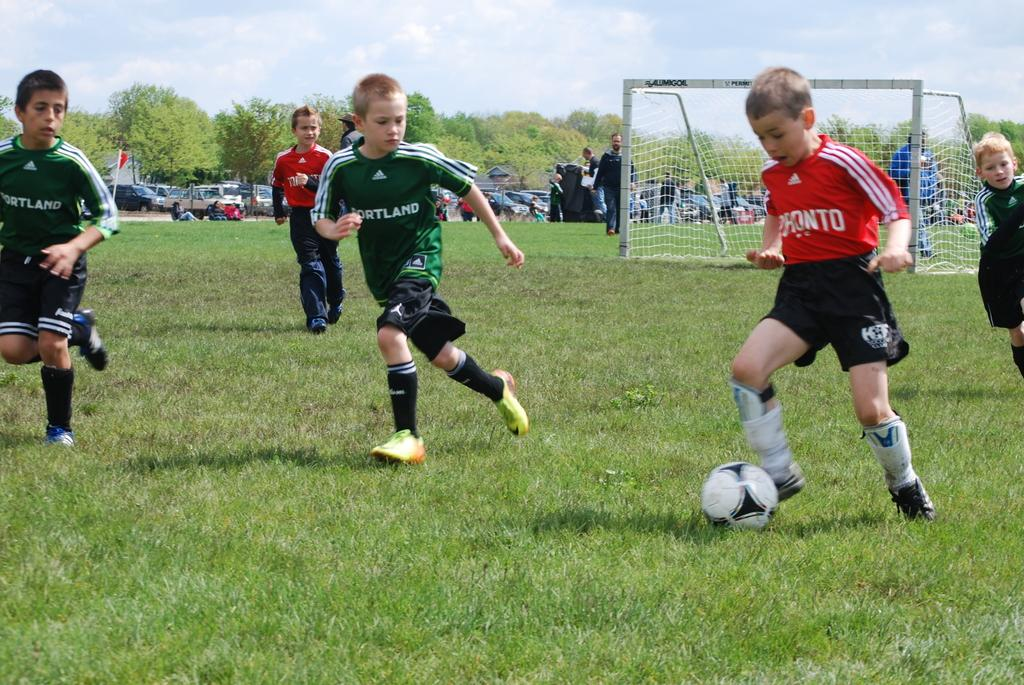<image>
Create a compact narrative representing the image presented. A boy in a red jersey that says pronto kicks a soccer ball away from several players on the other team. 